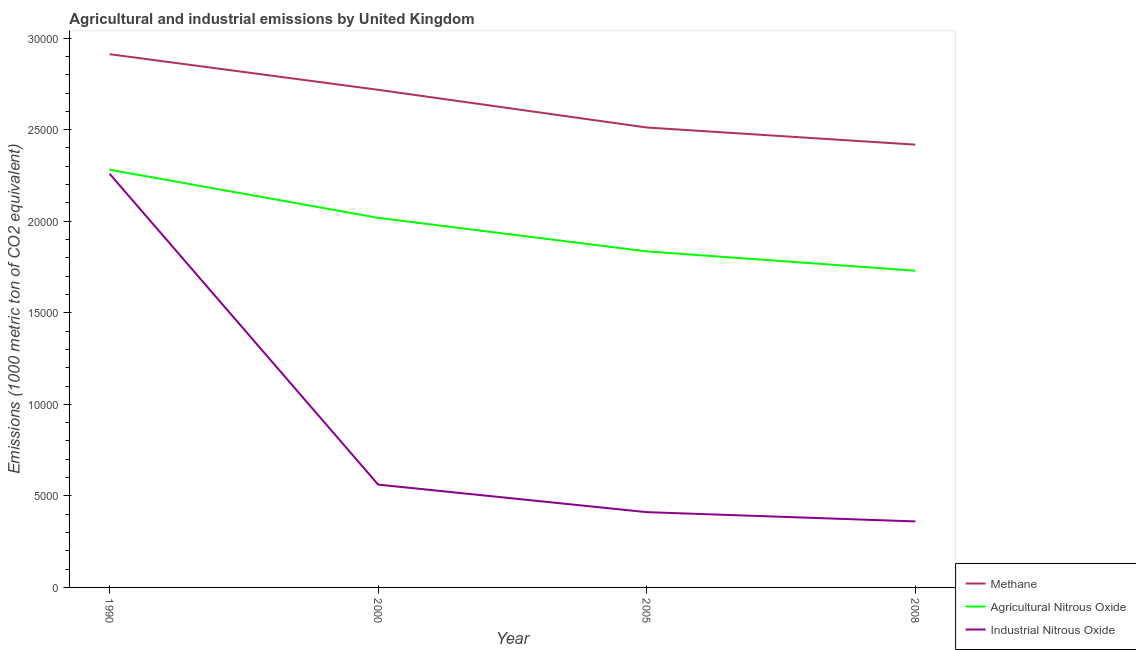Is the number of lines equal to the number of legend labels?
Offer a very short reply. Yes. What is the amount of methane emissions in 1990?
Offer a very short reply. 2.91e+04. Across all years, what is the maximum amount of industrial nitrous oxide emissions?
Offer a very short reply. 2.26e+04. Across all years, what is the minimum amount of methane emissions?
Offer a very short reply. 2.42e+04. In which year was the amount of industrial nitrous oxide emissions maximum?
Give a very brief answer. 1990. In which year was the amount of agricultural nitrous oxide emissions minimum?
Make the answer very short. 2008. What is the total amount of agricultural nitrous oxide emissions in the graph?
Your response must be concise. 7.86e+04. What is the difference between the amount of methane emissions in 2000 and that in 2008?
Make the answer very short. 2997.1. What is the difference between the amount of methane emissions in 2008 and the amount of agricultural nitrous oxide emissions in 1990?
Offer a terse response. 1367.2. What is the average amount of agricultural nitrous oxide emissions per year?
Provide a succinct answer. 1.97e+04. In the year 2000, what is the difference between the amount of industrial nitrous oxide emissions and amount of methane emissions?
Your answer should be very brief. -2.16e+04. What is the ratio of the amount of industrial nitrous oxide emissions in 2005 to that in 2008?
Give a very brief answer. 1.14. Is the difference between the amount of industrial nitrous oxide emissions in 2005 and 2008 greater than the difference between the amount of agricultural nitrous oxide emissions in 2005 and 2008?
Provide a succinct answer. No. What is the difference between the highest and the second highest amount of industrial nitrous oxide emissions?
Your response must be concise. 1.70e+04. What is the difference between the highest and the lowest amount of industrial nitrous oxide emissions?
Your response must be concise. 1.90e+04. Is the sum of the amount of industrial nitrous oxide emissions in 2005 and 2008 greater than the maximum amount of agricultural nitrous oxide emissions across all years?
Give a very brief answer. No. Is the amount of methane emissions strictly greater than the amount of agricultural nitrous oxide emissions over the years?
Your response must be concise. Yes. Is the amount of industrial nitrous oxide emissions strictly less than the amount of methane emissions over the years?
Ensure brevity in your answer.  Yes. What is the difference between two consecutive major ticks on the Y-axis?
Your response must be concise. 5000. Are the values on the major ticks of Y-axis written in scientific E-notation?
Give a very brief answer. No. Does the graph contain grids?
Make the answer very short. No. How many legend labels are there?
Your response must be concise. 3. What is the title of the graph?
Your answer should be very brief. Agricultural and industrial emissions by United Kingdom. What is the label or title of the Y-axis?
Provide a succinct answer. Emissions (1000 metric ton of CO2 equivalent). What is the Emissions (1000 metric ton of CO2 equivalent) of Methane in 1990?
Your answer should be compact. 2.91e+04. What is the Emissions (1000 metric ton of CO2 equivalent) in Agricultural Nitrous Oxide in 1990?
Give a very brief answer. 2.28e+04. What is the Emissions (1000 metric ton of CO2 equivalent) of Industrial Nitrous Oxide in 1990?
Ensure brevity in your answer.  2.26e+04. What is the Emissions (1000 metric ton of CO2 equivalent) of Methane in 2000?
Make the answer very short. 2.72e+04. What is the Emissions (1000 metric ton of CO2 equivalent) in Agricultural Nitrous Oxide in 2000?
Your answer should be very brief. 2.02e+04. What is the Emissions (1000 metric ton of CO2 equivalent) in Industrial Nitrous Oxide in 2000?
Provide a short and direct response. 5616. What is the Emissions (1000 metric ton of CO2 equivalent) of Methane in 2005?
Offer a very short reply. 2.51e+04. What is the Emissions (1000 metric ton of CO2 equivalent) of Agricultural Nitrous Oxide in 2005?
Offer a terse response. 1.84e+04. What is the Emissions (1000 metric ton of CO2 equivalent) in Industrial Nitrous Oxide in 2005?
Give a very brief answer. 4111.2. What is the Emissions (1000 metric ton of CO2 equivalent) of Methane in 2008?
Give a very brief answer. 2.42e+04. What is the Emissions (1000 metric ton of CO2 equivalent) of Agricultural Nitrous Oxide in 2008?
Make the answer very short. 1.73e+04. What is the Emissions (1000 metric ton of CO2 equivalent) of Industrial Nitrous Oxide in 2008?
Your response must be concise. 3604.6. Across all years, what is the maximum Emissions (1000 metric ton of CO2 equivalent) of Methane?
Provide a succinct answer. 2.91e+04. Across all years, what is the maximum Emissions (1000 metric ton of CO2 equivalent) in Agricultural Nitrous Oxide?
Your answer should be very brief. 2.28e+04. Across all years, what is the maximum Emissions (1000 metric ton of CO2 equivalent) of Industrial Nitrous Oxide?
Offer a terse response. 2.26e+04. Across all years, what is the minimum Emissions (1000 metric ton of CO2 equivalent) in Methane?
Your response must be concise. 2.42e+04. Across all years, what is the minimum Emissions (1000 metric ton of CO2 equivalent) of Agricultural Nitrous Oxide?
Provide a short and direct response. 1.73e+04. Across all years, what is the minimum Emissions (1000 metric ton of CO2 equivalent) of Industrial Nitrous Oxide?
Offer a terse response. 3604.6. What is the total Emissions (1000 metric ton of CO2 equivalent) in Methane in the graph?
Make the answer very short. 1.06e+05. What is the total Emissions (1000 metric ton of CO2 equivalent) in Agricultural Nitrous Oxide in the graph?
Your answer should be very brief. 7.86e+04. What is the total Emissions (1000 metric ton of CO2 equivalent) in Industrial Nitrous Oxide in the graph?
Offer a terse response. 3.59e+04. What is the difference between the Emissions (1000 metric ton of CO2 equivalent) of Methane in 1990 and that in 2000?
Provide a short and direct response. 1944.1. What is the difference between the Emissions (1000 metric ton of CO2 equivalent) in Agricultural Nitrous Oxide in 1990 and that in 2000?
Offer a very short reply. 2628.9. What is the difference between the Emissions (1000 metric ton of CO2 equivalent) in Industrial Nitrous Oxide in 1990 and that in 2000?
Provide a succinct answer. 1.70e+04. What is the difference between the Emissions (1000 metric ton of CO2 equivalent) of Methane in 1990 and that in 2005?
Offer a very short reply. 4004.1. What is the difference between the Emissions (1000 metric ton of CO2 equivalent) of Agricultural Nitrous Oxide in 1990 and that in 2005?
Offer a terse response. 4460.9. What is the difference between the Emissions (1000 metric ton of CO2 equivalent) in Industrial Nitrous Oxide in 1990 and that in 2005?
Your response must be concise. 1.85e+04. What is the difference between the Emissions (1000 metric ton of CO2 equivalent) in Methane in 1990 and that in 2008?
Offer a very short reply. 4941.2. What is the difference between the Emissions (1000 metric ton of CO2 equivalent) in Agricultural Nitrous Oxide in 1990 and that in 2008?
Your answer should be compact. 5516.7. What is the difference between the Emissions (1000 metric ton of CO2 equivalent) of Industrial Nitrous Oxide in 1990 and that in 2008?
Make the answer very short. 1.90e+04. What is the difference between the Emissions (1000 metric ton of CO2 equivalent) in Methane in 2000 and that in 2005?
Your answer should be very brief. 2060. What is the difference between the Emissions (1000 metric ton of CO2 equivalent) of Agricultural Nitrous Oxide in 2000 and that in 2005?
Provide a short and direct response. 1832. What is the difference between the Emissions (1000 metric ton of CO2 equivalent) of Industrial Nitrous Oxide in 2000 and that in 2005?
Your response must be concise. 1504.8. What is the difference between the Emissions (1000 metric ton of CO2 equivalent) of Methane in 2000 and that in 2008?
Your response must be concise. 2997.1. What is the difference between the Emissions (1000 metric ton of CO2 equivalent) in Agricultural Nitrous Oxide in 2000 and that in 2008?
Ensure brevity in your answer.  2887.8. What is the difference between the Emissions (1000 metric ton of CO2 equivalent) of Industrial Nitrous Oxide in 2000 and that in 2008?
Your answer should be compact. 2011.4. What is the difference between the Emissions (1000 metric ton of CO2 equivalent) of Methane in 2005 and that in 2008?
Provide a short and direct response. 937.1. What is the difference between the Emissions (1000 metric ton of CO2 equivalent) in Agricultural Nitrous Oxide in 2005 and that in 2008?
Keep it short and to the point. 1055.8. What is the difference between the Emissions (1000 metric ton of CO2 equivalent) in Industrial Nitrous Oxide in 2005 and that in 2008?
Provide a short and direct response. 506.6. What is the difference between the Emissions (1000 metric ton of CO2 equivalent) in Methane in 1990 and the Emissions (1000 metric ton of CO2 equivalent) in Agricultural Nitrous Oxide in 2000?
Ensure brevity in your answer.  8937.3. What is the difference between the Emissions (1000 metric ton of CO2 equivalent) in Methane in 1990 and the Emissions (1000 metric ton of CO2 equivalent) in Industrial Nitrous Oxide in 2000?
Your answer should be very brief. 2.35e+04. What is the difference between the Emissions (1000 metric ton of CO2 equivalent) of Agricultural Nitrous Oxide in 1990 and the Emissions (1000 metric ton of CO2 equivalent) of Industrial Nitrous Oxide in 2000?
Your response must be concise. 1.72e+04. What is the difference between the Emissions (1000 metric ton of CO2 equivalent) in Methane in 1990 and the Emissions (1000 metric ton of CO2 equivalent) in Agricultural Nitrous Oxide in 2005?
Offer a terse response. 1.08e+04. What is the difference between the Emissions (1000 metric ton of CO2 equivalent) in Methane in 1990 and the Emissions (1000 metric ton of CO2 equivalent) in Industrial Nitrous Oxide in 2005?
Offer a very short reply. 2.50e+04. What is the difference between the Emissions (1000 metric ton of CO2 equivalent) of Agricultural Nitrous Oxide in 1990 and the Emissions (1000 metric ton of CO2 equivalent) of Industrial Nitrous Oxide in 2005?
Provide a succinct answer. 1.87e+04. What is the difference between the Emissions (1000 metric ton of CO2 equivalent) in Methane in 1990 and the Emissions (1000 metric ton of CO2 equivalent) in Agricultural Nitrous Oxide in 2008?
Offer a very short reply. 1.18e+04. What is the difference between the Emissions (1000 metric ton of CO2 equivalent) in Methane in 1990 and the Emissions (1000 metric ton of CO2 equivalent) in Industrial Nitrous Oxide in 2008?
Your answer should be very brief. 2.55e+04. What is the difference between the Emissions (1000 metric ton of CO2 equivalent) in Agricultural Nitrous Oxide in 1990 and the Emissions (1000 metric ton of CO2 equivalent) in Industrial Nitrous Oxide in 2008?
Make the answer very short. 1.92e+04. What is the difference between the Emissions (1000 metric ton of CO2 equivalent) of Methane in 2000 and the Emissions (1000 metric ton of CO2 equivalent) of Agricultural Nitrous Oxide in 2005?
Ensure brevity in your answer.  8825.2. What is the difference between the Emissions (1000 metric ton of CO2 equivalent) in Methane in 2000 and the Emissions (1000 metric ton of CO2 equivalent) in Industrial Nitrous Oxide in 2005?
Your answer should be compact. 2.31e+04. What is the difference between the Emissions (1000 metric ton of CO2 equivalent) of Agricultural Nitrous Oxide in 2000 and the Emissions (1000 metric ton of CO2 equivalent) of Industrial Nitrous Oxide in 2005?
Ensure brevity in your answer.  1.61e+04. What is the difference between the Emissions (1000 metric ton of CO2 equivalent) in Methane in 2000 and the Emissions (1000 metric ton of CO2 equivalent) in Agricultural Nitrous Oxide in 2008?
Your answer should be compact. 9881. What is the difference between the Emissions (1000 metric ton of CO2 equivalent) of Methane in 2000 and the Emissions (1000 metric ton of CO2 equivalent) of Industrial Nitrous Oxide in 2008?
Offer a very short reply. 2.36e+04. What is the difference between the Emissions (1000 metric ton of CO2 equivalent) in Agricultural Nitrous Oxide in 2000 and the Emissions (1000 metric ton of CO2 equivalent) in Industrial Nitrous Oxide in 2008?
Ensure brevity in your answer.  1.66e+04. What is the difference between the Emissions (1000 metric ton of CO2 equivalent) in Methane in 2005 and the Emissions (1000 metric ton of CO2 equivalent) in Agricultural Nitrous Oxide in 2008?
Make the answer very short. 7821. What is the difference between the Emissions (1000 metric ton of CO2 equivalent) of Methane in 2005 and the Emissions (1000 metric ton of CO2 equivalent) of Industrial Nitrous Oxide in 2008?
Your response must be concise. 2.15e+04. What is the difference between the Emissions (1000 metric ton of CO2 equivalent) of Agricultural Nitrous Oxide in 2005 and the Emissions (1000 metric ton of CO2 equivalent) of Industrial Nitrous Oxide in 2008?
Offer a very short reply. 1.47e+04. What is the average Emissions (1000 metric ton of CO2 equivalent) in Methane per year?
Offer a very short reply. 2.64e+04. What is the average Emissions (1000 metric ton of CO2 equivalent) in Agricultural Nitrous Oxide per year?
Your answer should be compact. 1.97e+04. What is the average Emissions (1000 metric ton of CO2 equivalent) in Industrial Nitrous Oxide per year?
Offer a terse response. 8981.2. In the year 1990, what is the difference between the Emissions (1000 metric ton of CO2 equivalent) in Methane and Emissions (1000 metric ton of CO2 equivalent) in Agricultural Nitrous Oxide?
Provide a short and direct response. 6308.4. In the year 1990, what is the difference between the Emissions (1000 metric ton of CO2 equivalent) in Methane and Emissions (1000 metric ton of CO2 equivalent) in Industrial Nitrous Oxide?
Offer a terse response. 6529.3. In the year 1990, what is the difference between the Emissions (1000 metric ton of CO2 equivalent) of Agricultural Nitrous Oxide and Emissions (1000 metric ton of CO2 equivalent) of Industrial Nitrous Oxide?
Your answer should be compact. 220.9. In the year 2000, what is the difference between the Emissions (1000 metric ton of CO2 equivalent) of Methane and Emissions (1000 metric ton of CO2 equivalent) of Agricultural Nitrous Oxide?
Provide a short and direct response. 6993.2. In the year 2000, what is the difference between the Emissions (1000 metric ton of CO2 equivalent) of Methane and Emissions (1000 metric ton of CO2 equivalent) of Industrial Nitrous Oxide?
Make the answer very short. 2.16e+04. In the year 2000, what is the difference between the Emissions (1000 metric ton of CO2 equivalent) in Agricultural Nitrous Oxide and Emissions (1000 metric ton of CO2 equivalent) in Industrial Nitrous Oxide?
Offer a very short reply. 1.46e+04. In the year 2005, what is the difference between the Emissions (1000 metric ton of CO2 equivalent) in Methane and Emissions (1000 metric ton of CO2 equivalent) in Agricultural Nitrous Oxide?
Give a very brief answer. 6765.2. In the year 2005, what is the difference between the Emissions (1000 metric ton of CO2 equivalent) in Methane and Emissions (1000 metric ton of CO2 equivalent) in Industrial Nitrous Oxide?
Your answer should be compact. 2.10e+04. In the year 2005, what is the difference between the Emissions (1000 metric ton of CO2 equivalent) in Agricultural Nitrous Oxide and Emissions (1000 metric ton of CO2 equivalent) in Industrial Nitrous Oxide?
Offer a terse response. 1.42e+04. In the year 2008, what is the difference between the Emissions (1000 metric ton of CO2 equivalent) in Methane and Emissions (1000 metric ton of CO2 equivalent) in Agricultural Nitrous Oxide?
Your answer should be very brief. 6883.9. In the year 2008, what is the difference between the Emissions (1000 metric ton of CO2 equivalent) in Methane and Emissions (1000 metric ton of CO2 equivalent) in Industrial Nitrous Oxide?
Keep it short and to the point. 2.06e+04. In the year 2008, what is the difference between the Emissions (1000 metric ton of CO2 equivalent) of Agricultural Nitrous Oxide and Emissions (1000 metric ton of CO2 equivalent) of Industrial Nitrous Oxide?
Your answer should be compact. 1.37e+04. What is the ratio of the Emissions (1000 metric ton of CO2 equivalent) of Methane in 1990 to that in 2000?
Provide a succinct answer. 1.07. What is the ratio of the Emissions (1000 metric ton of CO2 equivalent) of Agricultural Nitrous Oxide in 1990 to that in 2000?
Make the answer very short. 1.13. What is the ratio of the Emissions (1000 metric ton of CO2 equivalent) in Industrial Nitrous Oxide in 1990 to that in 2000?
Your answer should be compact. 4.02. What is the ratio of the Emissions (1000 metric ton of CO2 equivalent) in Methane in 1990 to that in 2005?
Provide a short and direct response. 1.16. What is the ratio of the Emissions (1000 metric ton of CO2 equivalent) of Agricultural Nitrous Oxide in 1990 to that in 2005?
Offer a terse response. 1.24. What is the ratio of the Emissions (1000 metric ton of CO2 equivalent) in Industrial Nitrous Oxide in 1990 to that in 2005?
Keep it short and to the point. 5.5. What is the ratio of the Emissions (1000 metric ton of CO2 equivalent) of Methane in 1990 to that in 2008?
Give a very brief answer. 1.2. What is the ratio of the Emissions (1000 metric ton of CO2 equivalent) of Agricultural Nitrous Oxide in 1990 to that in 2008?
Provide a short and direct response. 1.32. What is the ratio of the Emissions (1000 metric ton of CO2 equivalent) of Industrial Nitrous Oxide in 1990 to that in 2008?
Your answer should be compact. 6.27. What is the ratio of the Emissions (1000 metric ton of CO2 equivalent) in Methane in 2000 to that in 2005?
Provide a short and direct response. 1.08. What is the ratio of the Emissions (1000 metric ton of CO2 equivalent) in Agricultural Nitrous Oxide in 2000 to that in 2005?
Provide a short and direct response. 1.1. What is the ratio of the Emissions (1000 metric ton of CO2 equivalent) in Industrial Nitrous Oxide in 2000 to that in 2005?
Your answer should be compact. 1.37. What is the ratio of the Emissions (1000 metric ton of CO2 equivalent) in Methane in 2000 to that in 2008?
Make the answer very short. 1.12. What is the ratio of the Emissions (1000 metric ton of CO2 equivalent) of Agricultural Nitrous Oxide in 2000 to that in 2008?
Provide a succinct answer. 1.17. What is the ratio of the Emissions (1000 metric ton of CO2 equivalent) of Industrial Nitrous Oxide in 2000 to that in 2008?
Keep it short and to the point. 1.56. What is the ratio of the Emissions (1000 metric ton of CO2 equivalent) of Methane in 2005 to that in 2008?
Provide a succinct answer. 1.04. What is the ratio of the Emissions (1000 metric ton of CO2 equivalent) of Agricultural Nitrous Oxide in 2005 to that in 2008?
Keep it short and to the point. 1.06. What is the ratio of the Emissions (1000 metric ton of CO2 equivalent) in Industrial Nitrous Oxide in 2005 to that in 2008?
Offer a very short reply. 1.14. What is the difference between the highest and the second highest Emissions (1000 metric ton of CO2 equivalent) of Methane?
Offer a terse response. 1944.1. What is the difference between the highest and the second highest Emissions (1000 metric ton of CO2 equivalent) of Agricultural Nitrous Oxide?
Make the answer very short. 2628.9. What is the difference between the highest and the second highest Emissions (1000 metric ton of CO2 equivalent) in Industrial Nitrous Oxide?
Your answer should be compact. 1.70e+04. What is the difference between the highest and the lowest Emissions (1000 metric ton of CO2 equivalent) in Methane?
Give a very brief answer. 4941.2. What is the difference between the highest and the lowest Emissions (1000 metric ton of CO2 equivalent) in Agricultural Nitrous Oxide?
Provide a succinct answer. 5516.7. What is the difference between the highest and the lowest Emissions (1000 metric ton of CO2 equivalent) of Industrial Nitrous Oxide?
Your answer should be compact. 1.90e+04. 